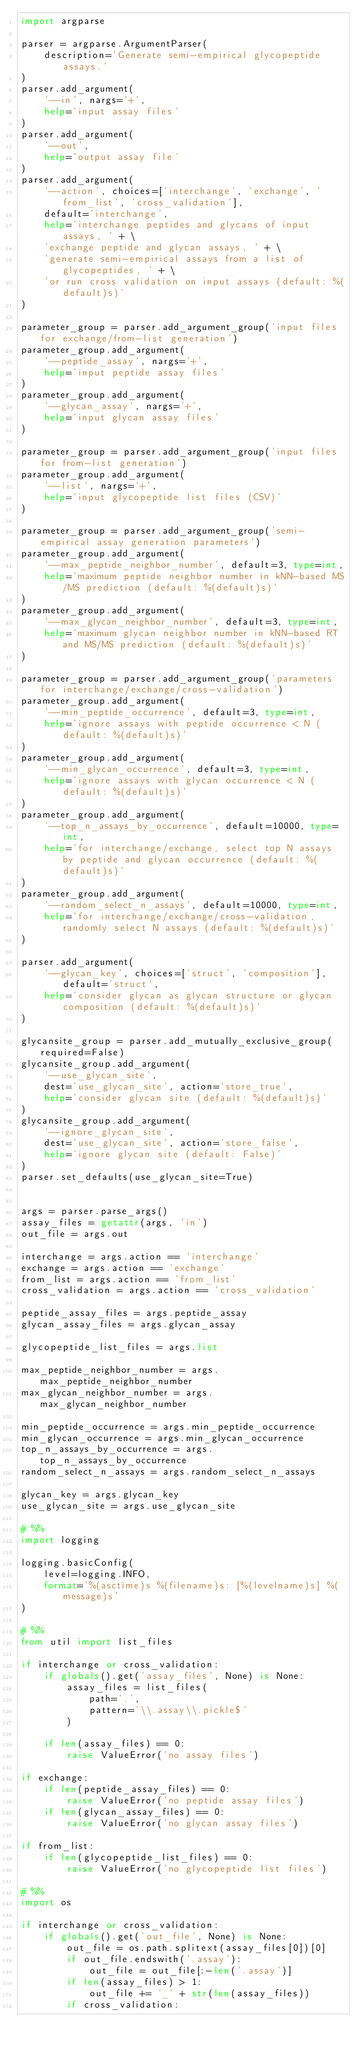Convert code to text. <code><loc_0><loc_0><loc_500><loc_500><_Python_>import argparse

parser = argparse.ArgumentParser(
    description='Generate semi-empirical glycopeptide assays.'
)
parser.add_argument(
    '--in', nargs='+',
    help='input assay files'
)
parser.add_argument(
    '--out',
    help='output assay file'
)
parser.add_argument(
    '--action', choices=['interchange', 'exchange', 'from_list', 'cross_validation'],
    default='interchange',
    help='interchange peptides and glycans of input assays, ' + \
    'exchange peptide and glycan assays, ' + \
    'generate semi-empirical assays from a list of glycopeptides, ' + \
    'or run cross validation on input assays (default: %(default)s)'
)

parameter_group = parser.add_argument_group('input files for exchange/from-list generation') 
parameter_group.add_argument(
    '--peptide_assay', nargs='+',
    help='input peptide assay files'
)
parameter_group.add_argument(
    '--glycan_assay', nargs='+',
    help='input glycan assay files'
)

parameter_group = parser.add_argument_group('input files for from-list generation') 
parameter_group.add_argument(
    '--list', nargs='+',
    help='input glycopeptide list files (CSV)'
)

parameter_group = parser.add_argument_group('semi-empirical assay generation parameters') 
parameter_group.add_argument(
    '--max_peptide_neighbor_number', default=3, type=int,
    help='maximum peptide neighbor number in kNN-based MS/MS prediction (default: %(default)s)'
)
parameter_group.add_argument(
    '--max_glycan_neighbor_number', default=3, type=int,
    help='maximum glycan neighbor number in kNN-based RT and MS/MS prediction (default: %(default)s)'
)

parameter_group = parser.add_argument_group('parameters for interchange/exchange/cross-validation') 
parameter_group.add_argument(
    '--min_peptide_occurrence', default=3, type=int,
    help='ignore assays with peptide occurrence < N (default: %(default)s)'
)
parameter_group.add_argument(
    '--min_glycan_occurrence', default=3, type=int,
    help='ignore assays with glycan occurrence < N (default: %(default)s)'
)
parameter_group.add_argument(
    '--top_n_assays_by_occurrence', default=10000, type=int,
    help='for interchange/exchange, select top N assays by peptide and glycan occurrence (default: %(default)s)'
)
parameter_group.add_argument(
    '--random_select_n_assays', default=10000, type=int,
    help='for interchange/exchange/cross-validation, randomly select N assays (default: %(default)s)'
)

parser.add_argument(
    '--glycan_key', choices=['struct', 'composition'], default='struct',
    help='consider glycan as glycan structure or glycan composition (default: %(default)s)'
)

glycansite_group = parser.add_mutually_exclusive_group(required=False)
glycansite_group.add_argument(
    '--use_glycan_site', 
    dest='use_glycan_site', action='store_true', 
    help='consider glycan site (default: %(default)s)'
)
glycansite_group.add_argument(
    '--ignore_glycan_site', 
    dest='use_glycan_site', action='store_false',
    help='ignore glycan site (default: False)'
)
parser.set_defaults(use_glycan_site=True)


args = parser.parse_args()
assay_files = getattr(args, 'in')
out_file = args.out

interchange = args.action == 'interchange'
exchange = args.action == 'exchange'
from_list = args.action == 'from_list'
cross_validation = args.action == 'cross_validation'

peptide_assay_files = args.peptide_assay
glycan_assay_files = args.glycan_assay

glycopeptide_list_files = args.list

max_peptide_neighbor_number = args.max_peptide_neighbor_number
max_glycan_neighbor_number = args.max_glycan_neighbor_number

min_peptide_occurrence = args.min_peptide_occurrence
min_glycan_occurrence = args.min_glycan_occurrence
top_n_assays_by_occurrence = args.top_n_assays_by_occurrence
random_select_n_assays = args.random_select_n_assays

glycan_key = args.glycan_key
use_glycan_site = args.use_glycan_site

# %%
import logging

logging.basicConfig(
    level=logging.INFO, 
    format='%(asctime)s %(filename)s: [%(levelname)s] %(message)s'
)

# %%
from util import list_files

if interchange or cross_validation:
    if globals().get('assay_files', None) is None:
        assay_files = list_files(
            path='.', 
            pattern='\\.assay\\.pickle$'
        )
        
    if len(assay_files) == 0:
        raise ValueError('no assay files')
        
if exchange:
    if len(peptide_assay_files) == 0:
        raise ValueError('no peptide assay files')
    if len(glycan_assay_files) == 0:
        raise ValueError('no glycan assay files')
        
if from_list:
    if len(glycopeptide_list_files) == 0:
        raise ValueError('no glycopeptide list files')
    
# %%
import os

if interchange or cross_validation:
    if globals().get('out_file', None) is None:
        out_file = os.path.splitext(assay_files[0])[0]
        if out_file.endswith('.assay'):
            out_file = out_file[:-len('.assay')]
        if len(assay_files) > 1:
            out_file += '_' + str(len(assay_files))
        if cross_validation:</code> 